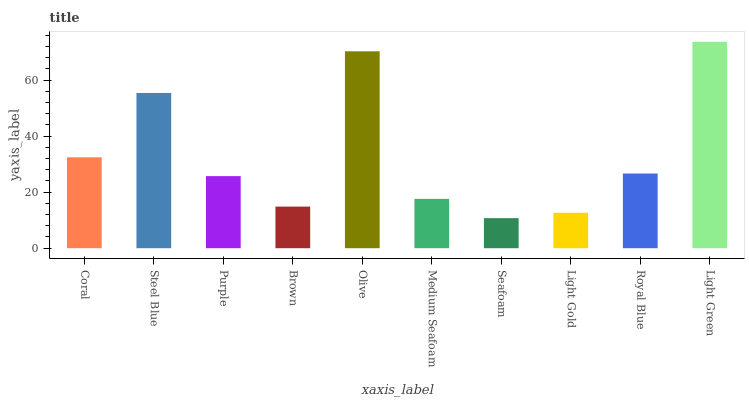Is Seafoam the minimum?
Answer yes or no. Yes. Is Light Green the maximum?
Answer yes or no. Yes. Is Steel Blue the minimum?
Answer yes or no. No. Is Steel Blue the maximum?
Answer yes or no. No. Is Steel Blue greater than Coral?
Answer yes or no. Yes. Is Coral less than Steel Blue?
Answer yes or no. Yes. Is Coral greater than Steel Blue?
Answer yes or no. No. Is Steel Blue less than Coral?
Answer yes or no. No. Is Royal Blue the high median?
Answer yes or no. Yes. Is Purple the low median?
Answer yes or no. Yes. Is Purple the high median?
Answer yes or no. No. Is Seafoam the low median?
Answer yes or no. No. 